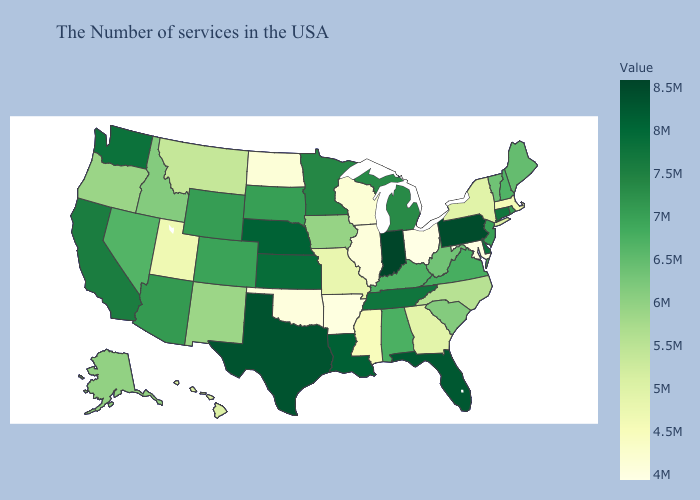Does South Dakota have a lower value than Wisconsin?
Short answer required. No. Does Pennsylvania have the lowest value in the USA?
Concise answer only. No. Among the states that border Michigan , does Wisconsin have the lowest value?
Concise answer only. No. Among the states that border Nebraska , which have the lowest value?
Quick response, please. Missouri. Which states hav the highest value in the Northeast?
Keep it brief. Pennsylvania. Does the map have missing data?
Short answer required. No. Does Indiana have the highest value in the USA?
Give a very brief answer. Yes. 